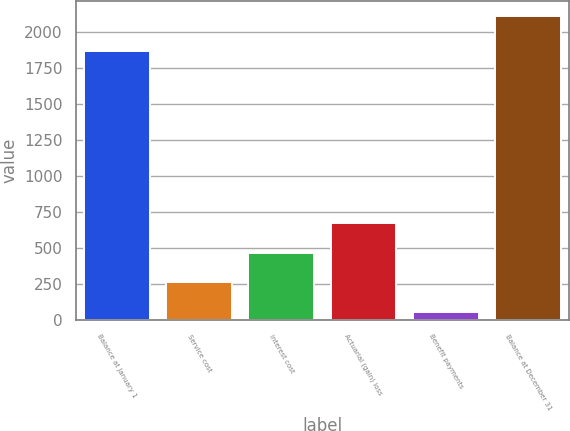Convert chart to OTSL. <chart><loc_0><loc_0><loc_500><loc_500><bar_chart><fcel>Balance at January 1<fcel>Service cost<fcel>Interest cost<fcel>Actuarial (gain) loss<fcel>Benefit payments<fcel>Balance at December 31<nl><fcel>1866<fcel>259.6<fcel>465.2<fcel>670.8<fcel>54<fcel>2110<nl></chart> 